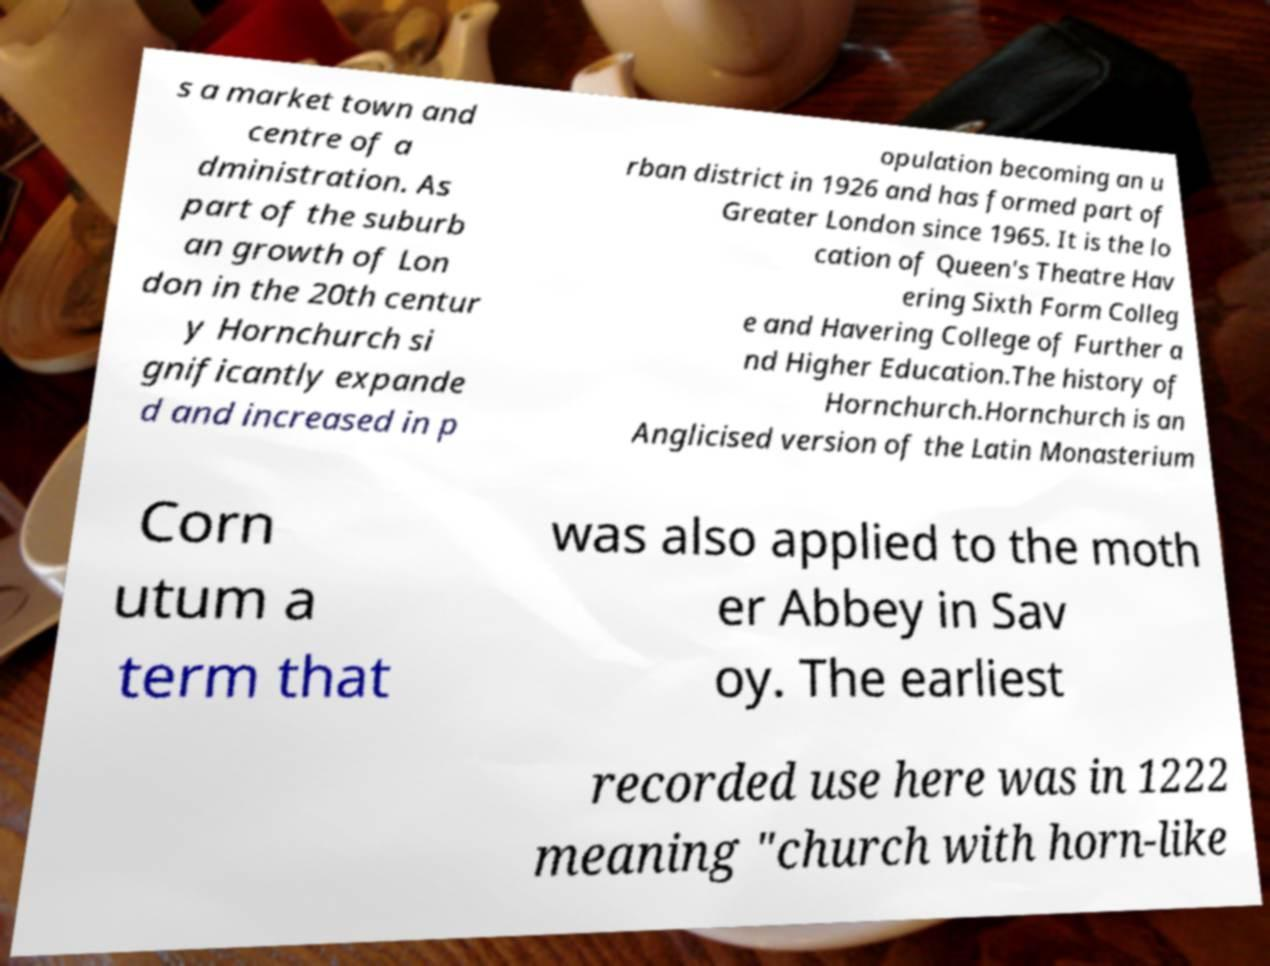Please identify and transcribe the text found in this image. s a market town and centre of a dministration. As part of the suburb an growth of Lon don in the 20th centur y Hornchurch si gnificantly expande d and increased in p opulation becoming an u rban district in 1926 and has formed part of Greater London since 1965. It is the lo cation of Queen's Theatre Hav ering Sixth Form Colleg e and Havering College of Further a nd Higher Education.The history of Hornchurch.Hornchurch is an Anglicised version of the Latin Monasterium Corn utum a term that was also applied to the moth er Abbey in Sav oy. The earliest recorded use here was in 1222 meaning "church with horn-like 